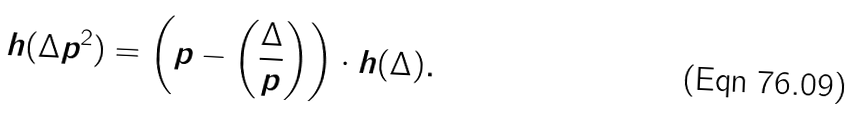Convert formula to latex. <formula><loc_0><loc_0><loc_500><loc_500>h ( \Delta p ^ { 2 } ) = \left ( p - \left ( \frac { \Delta } p \right ) \right ) \cdot h ( \Delta ) .</formula> 